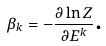Convert formula to latex. <formula><loc_0><loc_0><loc_500><loc_500>\beta _ { k } = - \frac { \partial \ln Z } { \partial E ^ { k } } \text {.}</formula> 